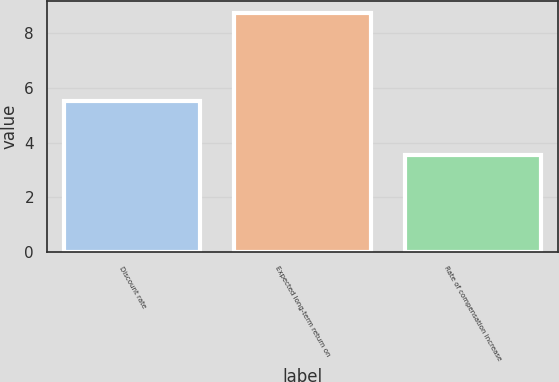Convert chart to OTSL. <chart><loc_0><loc_0><loc_500><loc_500><bar_chart><fcel>Discount rate<fcel>Expected long-term return on<fcel>Rate of compensation increase<nl><fcel>5.53<fcel>8.75<fcel>3.54<nl></chart> 